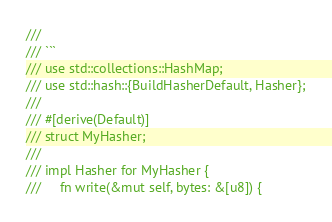<code> <loc_0><loc_0><loc_500><loc_500><_Rust_>///
/// ```
/// use std::collections::HashMap;
/// use std::hash::{BuildHasherDefault, Hasher};
///
/// #[derive(Default)]
/// struct MyHasher;
///
/// impl Hasher for MyHasher {
///     fn write(&mut self, bytes: &[u8]) {</code> 